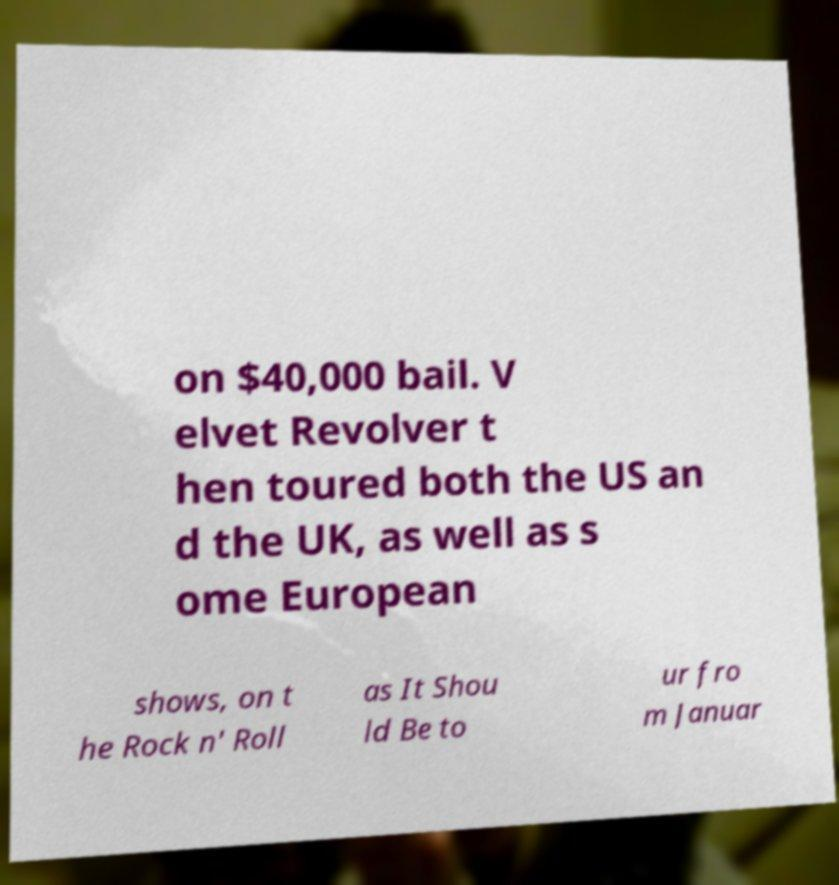Can you read and provide the text displayed in the image?This photo seems to have some interesting text. Can you extract and type it out for me? on $40,000 bail. V elvet Revolver t hen toured both the US an d the UK, as well as s ome European shows, on t he Rock n' Roll as It Shou ld Be to ur fro m Januar 